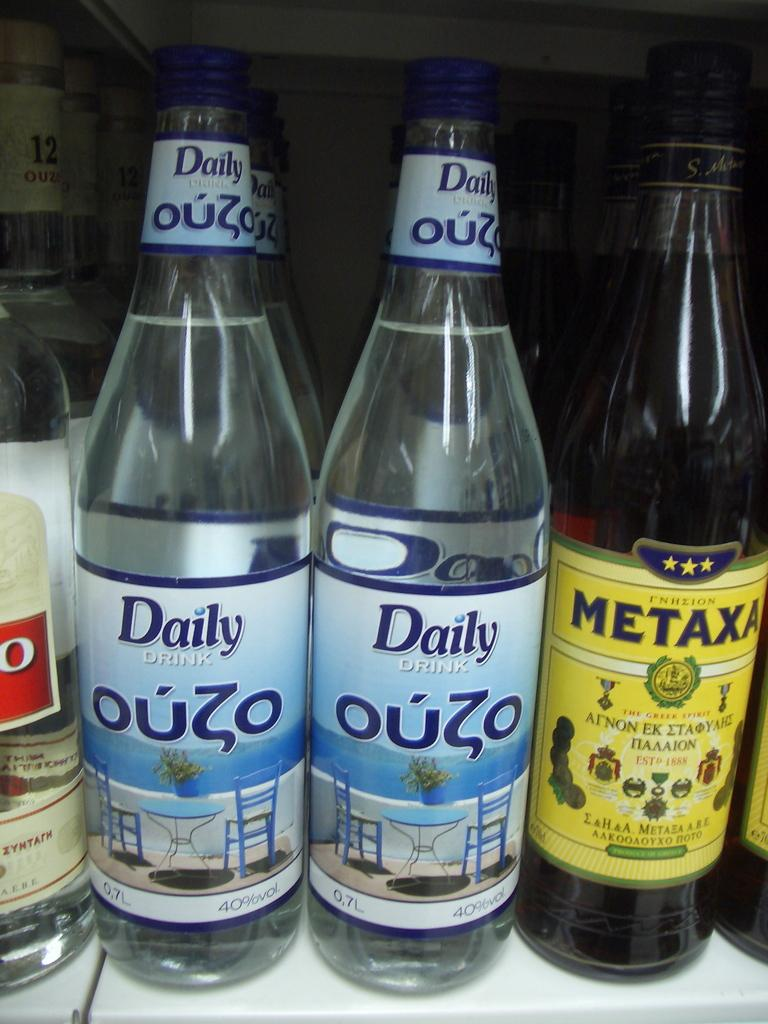<image>
Share a concise interpretation of the image provided. The white bottles of liquid are advertised as daily drink. 